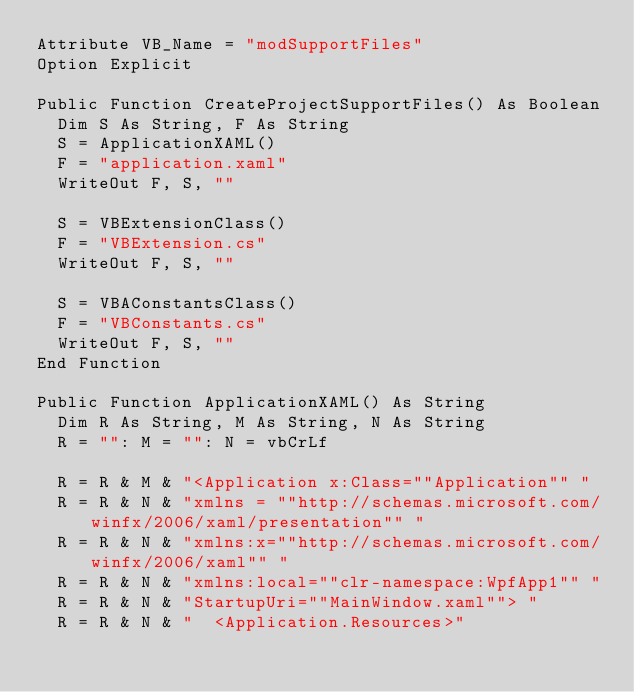Convert code to text. <code><loc_0><loc_0><loc_500><loc_500><_VisualBasic_>Attribute VB_Name = "modSupportFiles"
Option Explicit

Public Function CreateProjectSupportFiles() As Boolean
  Dim S As String, F As String
  S = ApplicationXAML()
  F = "application.xaml"
  WriteOut F, S, ""
  
  S = VBExtensionClass()
  F = "VBExtension.cs"
  WriteOut F, S, ""
  
  S = VBAConstantsClass()
  F = "VBConstants.cs"
  WriteOut F, S, ""
End Function

Public Function ApplicationXAML() As String
  Dim R As String, M As String, N As String
  R = "": M = "": N = vbCrLf
  
  R = R & M & "<Application x:Class=""Application"" "
  R = R & N & "xmlns = ""http://schemas.microsoft.com/winfx/2006/xaml/presentation"" "
  R = R & N & "xmlns:x=""http://schemas.microsoft.com/winfx/2006/xaml"" "
  R = R & N & "xmlns:local=""clr-namespace:WpfApp1"" "
  R = R & N & "StartupUri=""MainWindow.xaml""> "
  R = R & N & "  <Application.Resources>"</code> 